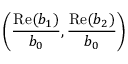<formula> <loc_0><loc_0><loc_500><loc_500>\left ( \frac { R e ( b _ { 1 } ) } { b _ { 0 } } , \frac { R e ( b _ { 2 } ) } { b _ { 0 } } \right )</formula> 